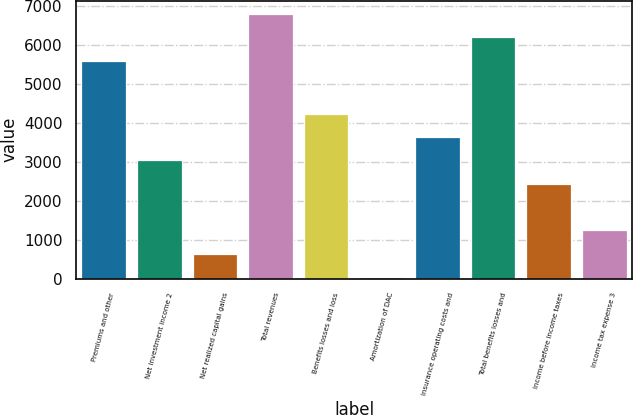Convert chart to OTSL. <chart><loc_0><loc_0><loc_500><loc_500><bar_chart><fcel>Premiums and other<fcel>Net investment income 2<fcel>Net realized capital gains<fcel>Total revenues<fcel>Benefits losses and loss<fcel>Amortization of DAC<fcel>Insurance operating costs and<fcel>Total benefits losses and<fcel>Income before income taxes<fcel>Income tax expense 3<nl><fcel>5598<fcel>3035<fcel>643<fcel>6794<fcel>4231<fcel>45<fcel>3633<fcel>6196<fcel>2437<fcel>1241<nl></chart> 